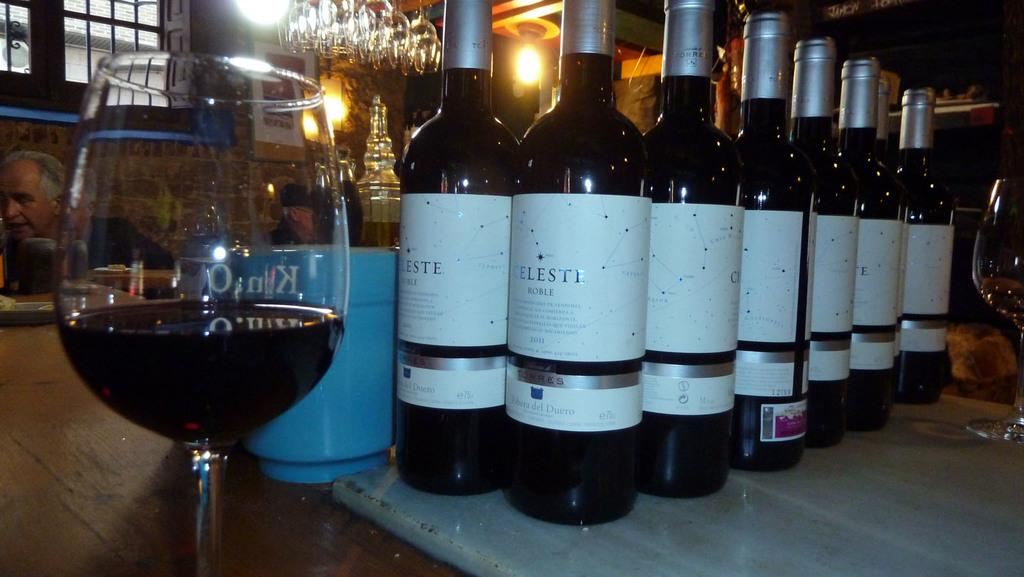<image>
Relay a brief, clear account of the picture shown. A table packed with Celesti wine bottles and glasses in a restaurant. 